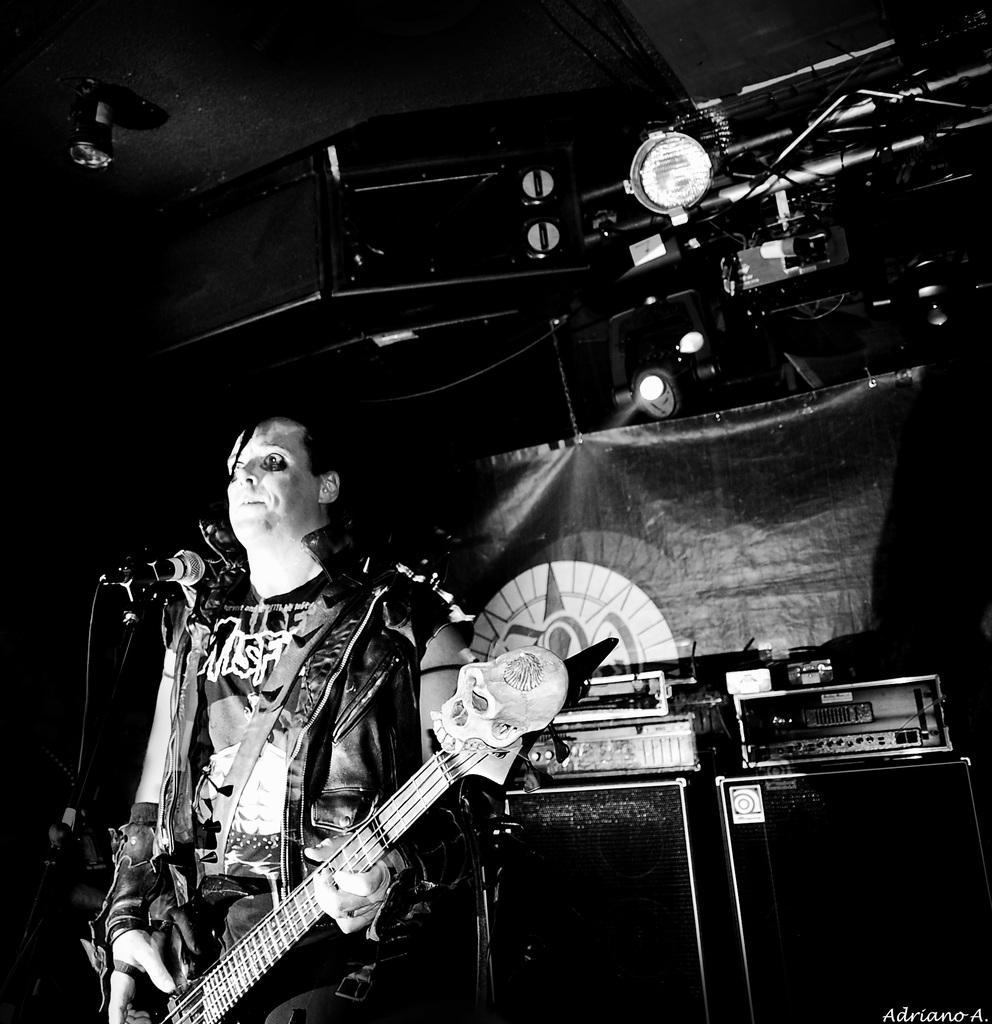What is the color scheme of the image? The image is in black and white. Can you describe the person in the image? There is a person in the image, and they are wearing a jacket. What is the person holding in the image? The person is holding a guitar. What can be seen in the background of the image? There are sound speakers, stands, and lights in the background. How many mice can be seen running around the person's feet in the image? There are no mice present in the image. What type of fang is visible on the person's face in the image? There are no fangs visible on the person's face in the image. 